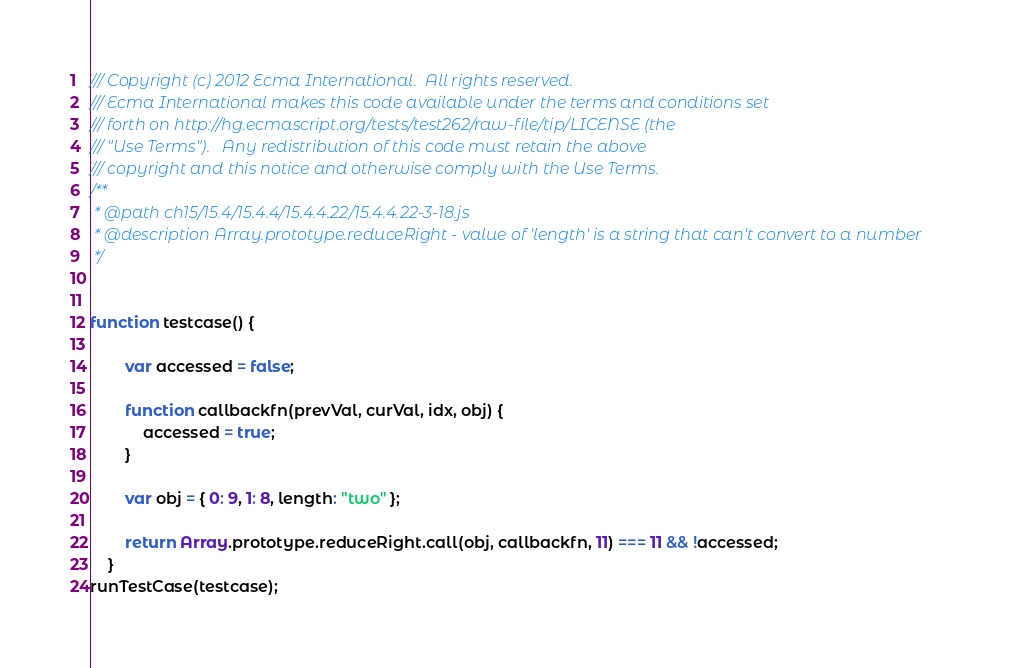Convert code to text. <code><loc_0><loc_0><loc_500><loc_500><_JavaScript_>/// Copyright (c) 2012 Ecma International.  All rights reserved. 
/// Ecma International makes this code available under the terms and conditions set
/// forth on http://hg.ecmascript.org/tests/test262/raw-file/tip/LICENSE (the 
/// "Use Terms").   Any redistribution of this code must retain the above 
/// copyright and this notice and otherwise comply with the Use Terms.
/**
 * @path ch15/15.4/15.4.4/15.4.4.22/15.4.4.22-3-18.js
 * @description Array.prototype.reduceRight - value of 'length' is a string that can't convert to a number
 */


function testcase() {

        var accessed = false;

        function callbackfn(prevVal, curVal, idx, obj) {
            accessed = true;
        }

        var obj = { 0: 9, 1: 8, length: "two" };

        return Array.prototype.reduceRight.call(obj, callbackfn, 11) === 11 && !accessed;
    }
runTestCase(testcase);
</code> 